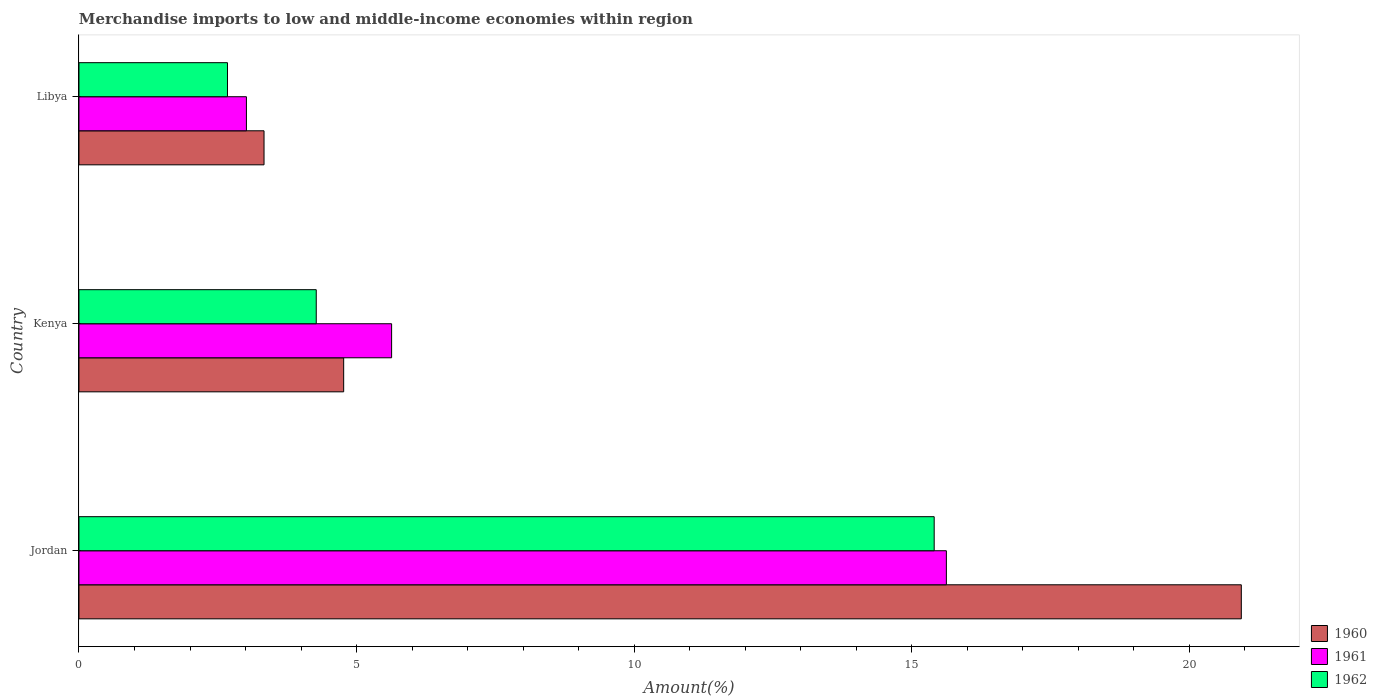Are the number of bars per tick equal to the number of legend labels?
Provide a short and direct response. Yes. How many bars are there on the 1st tick from the top?
Offer a terse response. 3. How many bars are there on the 3rd tick from the bottom?
Your response must be concise. 3. What is the label of the 2nd group of bars from the top?
Ensure brevity in your answer.  Kenya. In how many cases, is the number of bars for a given country not equal to the number of legend labels?
Provide a succinct answer. 0. What is the percentage of amount earned from merchandise imports in 1961 in Jordan?
Provide a succinct answer. 15.62. Across all countries, what is the maximum percentage of amount earned from merchandise imports in 1962?
Your answer should be compact. 15.4. Across all countries, what is the minimum percentage of amount earned from merchandise imports in 1961?
Your answer should be compact. 3.02. In which country was the percentage of amount earned from merchandise imports in 1960 maximum?
Offer a very short reply. Jordan. In which country was the percentage of amount earned from merchandise imports in 1960 minimum?
Offer a very short reply. Libya. What is the total percentage of amount earned from merchandise imports in 1962 in the graph?
Provide a short and direct response. 22.35. What is the difference between the percentage of amount earned from merchandise imports in 1960 in Jordan and that in Libya?
Offer a terse response. 17.6. What is the difference between the percentage of amount earned from merchandise imports in 1961 in Jordan and the percentage of amount earned from merchandise imports in 1960 in Kenya?
Your answer should be very brief. 10.85. What is the average percentage of amount earned from merchandise imports in 1962 per country?
Your answer should be compact. 7.45. What is the difference between the percentage of amount earned from merchandise imports in 1961 and percentage of amount earned from merchandise imports in 1962 in Jordan?
Your answer should be very brief. 0.22. What is the ratio of the percentage of amount earned from merchandise imports in 1962 in Kenya to that in Libya?
Keep it short and to the point. 1.6. Is the percentage of amount earned from merchandise imports in 1961 in Jordan less than that in Kenya?
Your response must be concise. No. Is the difference between the percentage of amount earned from merchandise imports in 1961 in Kenya and Libya greater than the difference between the percentage of amount earned from merchandise imports in 1962 in Kenya and Libya?
Offer a very short reply. Yes. What is the difference between the highest and the second highest percentage of amount earned from merchandise imports in 1962?
Your response must be concise. 11.13. What is the difference between the highest and the lowest percentage of amount earned from merchandise imports in 1961?
Keep it short and to the point. 12.61. In how many countries, is the percentage of amount earned from merchandise imports in 1960 greater than the average percentage of amount earned from merchandise imports in 1960 taken over all countries?
Give a very brief answer. 1. Is the sum of the percentage of amount earned from merchandise imports in 1960 in Jordan and Libya greater than the maximum percentage of amount earned from merchandise imports in 1962 across all countries?
Make the answer very short. Yes. What does the 3rd bar from the top in Jordan represents?
Offer a very short reply. 1960. What is the difference between two consecutive major ticks on the X-axis?
Provide a succinct answer. 5. Does the graph contain any zero values?
Provide a succinct answer. No. How many legend labels are there?
Keep it short and to the point. 3. How are the legend labels stacked?
Your answer should be compact. Vertical. What is the title of the graph?
Provide a succinct answer. Merchandise imports to low and middle-income economies within region. Does "2012" appear as one of the legend labels in the graph?
Ensure brevity in your answer.  No. What is the label or title of the X-axis?
Your response must be concise. Amount(%). What is the label or title of the Y-axis?
Provide a succinct answer. Country. What is the Amount(%) in 1960 in Jordan?
Give a very brief answer. 20.93. What is the Amount(%) in 1961 in Jordan?
Offer a very short reply. 15.62. What is the Amount(%) of 1962 in Jordan?
Offer a terse response. 15.4. What is the Amount(%) of 1960 in Kenya?
Your answer should be very brief. 4.77. What is the Amount(%) in 1961 in Kenya?
Your response must be concise. 5.63. What is the Amount(%) of 1962 in Kenya?
Provide a succinct answer. 4.27. What is the Amount(%) of 1960 in Libya?
Offer a very short reply. 3.33. What is the Amount(%) of 1961 in Libya?
Give a very brief answer. 3.02. What is the Amount(%) of 1962 in Libya?
Offer a terse response. 2.68. Across all countries, what is the maximum Amount(%) in 1960?
Your answer should be compact. 20.93. Across all countries, what is the maximum Amount(%) in 1961?
Ensure brevity in your answer.  15.62. Across all countries, what is the maximum Amount(%) in 1962?
Your answer should be compact. 15.4. Across all countries, what is the minimum Amount(%) of 1960?
Your response must be concise. 3.33. Across all countries, what is the minimum Amount(%) of 1961?
Offer a very short reply. 3.02. Across all countries, what is the minimum Amount(%) in 1962?
Your answer should be compact. 2.68. What is the total Amount(%) in 1960 in the graph?
Your response must be concise. 29.04. What is the total Amount(%) in 1961 in the graph?
Your answer should be very brief. 24.27. What is the total Amount(%) of 1962 in the graph?
Offer a terse response. 22.35. What is the difference between the Amount(%) of 1960 in Jordan and that in Kenya?
Make the answer very short. 16.17. What is the difference between the Amount(%) of 1961 in Jordan and that in Kenya?
Offer a terse response. 9.99. What is the difference between the Amount(%) in 1962 in Jordan and that in Kenya?
Your response must be concise. 11.13. What is the difference between the Amount(%) of 1960 in Jordan and that in Libya?
Your answer should be compact. 17.6. What is the difference between the Amount(%) in 1961 in Jordan and that in Libya?
Provide a short and direct response. 12.61. What is the difference between the Amount(%) in 1962 in Jordan and that in Libya?
Provide a short and direct response. 12.73. What is the difference between the Amount(%) of 1960 in Kenya and that in Libya?
Provide a succinct answer. 1.43. What is the difference between the Amount(%) of 1961 in Kenya and that in Libya?
Offer a terse response. 2.61. What is the difference between the Amount(%) of 1962 in Kenya and that in Libya?
Your response must be concise. 1.6. What is the difference between the Amount(%) of 1960 in Jordan and the Amount(%) of 1961 in Kenya?
Ensure brevity in your answer.  15.3. What is the difference between the Amount(%) in 1960 in Jordan and the Amount(%) in 1962 in Kenya?
Ensure brevity in your answer.  16.66. What is the difference between the Amount(%) in 1961 in Jordan and the Amount(%) in 1962 in Kenya?
Keep it short and to the point. 11.35. What is the difference between the Amount(%) in 1960 in Jordan and the Amount(%) in 1961 in Libya?
Give a very brief answer. 17.92. What is the difference between the Amount(%) in 1960 in Jordan and the Amount(%) in 1962 in Libya?
Your answer should be very brief. 18.26. What is the difference between the Amount(%) of 1961 in Jordan and the Amount(%) of 1962 in Libya?
Provide a short and direct response. 12.95. What is the difference between the Amount(%) in 1960 in Kenya and the Amount(%) in 1961 in Libya?
Your answer should be compact. 1.75. What is the difference between the Amount(%) in 1960 in Kenya and the Amount(%) in 1962 in Libya?
Your answer should be compact. 2.09. What is the difference between the Amount(%) in 1961 in Kenya and the Amount(%) in 1962 in Libya?
Give a very brief answer. 2.96. What is the average Amount(%) of 1960 per country?
Provide a succinct answer. 9.68. What is the average Amount(%) in 1961 per country?
Provide a short and direct response. 8.09. What is the average Amount(%) of 1962 per country?
Provide a succinct answer. 7.45. What is the difference between the Amount(%) of 1960 and Amount(%) of 1961 in Jordan?
Your answer should be compact. 5.31. What is the difference between the Amount(%) of 1960 and Amount(%) of 1962 in Jordan?
Make the answer very short. 5.53. What is the difference between the Amount(%) of 1961 and Amount(%) of 1962 in Jordan?
Keep it short and to the point. 0.22. What is the difference between the Amount(%) in 1960 and Amount(%) in 1961 in Kenya?
Make the answer very short. -0.86. What is the difference between the Amount(%) in 1960 and Amount(%) in 1962 in Kenya?
Your answer should be very brief. 0.49. What is the difference between the Amount(%) in 1961 and Amount(%) in 1962 in Kenya?
Your response must be concise. 1.36. What is the difference between the Amount(%) of 1960 and Amount(%) of 1961 in Libya?
Your response must be concise. 0.32. What is the difference between the Amount(%) in 1960 and Amount(%) in 1962 in Libya?
Keep it short and to the point. 0.66. What is the difference between the Amount(%) in 1961 and Amount(%) in 1962 in Libya?
Give a very brief answer. 0.34. What is the ratio of the Amount(%) of 1960 in Jordan to that in Kenya?
Provide a short and direct response. 4.39. What is the ratio of the Amount(%) of 1961 in Jordan to that in Kenya?
Ensure brevity in your answer.  2.77. What is the ratio of the Amount(%) in 1962 in Jordan to that in Kenya?
Your response must be concise. 3.6. What is the ratio of the Amount(%) of 1960 in Jordan to that in Libya?
Ensure brevity in your answer.  6.28. What is the ratio of the Amount(%) in 1961 in Jordan to that in Libya?
Your response must be concise. 5.18. What is the ratio of the Amount(%) in 1962 in Jordan to that in Libya?
Keep it short and to the point. 5.76. What is the ratio of the Amount(%) in 1960 in Kenya to that in Libya?
Your answer should be compact. 1.43. What is the ratio of the Amount(%) in 1961 in Kenya to that in Libya?
Make the answer very short. 1.87. What is the ratio of the Amount(%) of 1962 in Kenya to that in Libya?
Provide a succinct answer. 1.6. What is the difference between the highest and the second highest Amount(%) of 1960?
Your answer should be compact. 16.17. What is the difference between the highest and the second highest Amount(%) of 1961?
Your answer should be very brief. 9.99. What is the difference between the highest and the second highest Amount(%) of 1962?
Make the answer very short. 11.13. What is the difference between the highest and the lowest Amount(%) in 1960?
Make the answer very short. 17.6. What is the difference between the highest and the lowest Amount(%) of 1961?
Offer a terse response. 12.61. What is the difference between the highest and the lowest Amount(%) in 1962?
Provide a succinct answer. 12.73. 